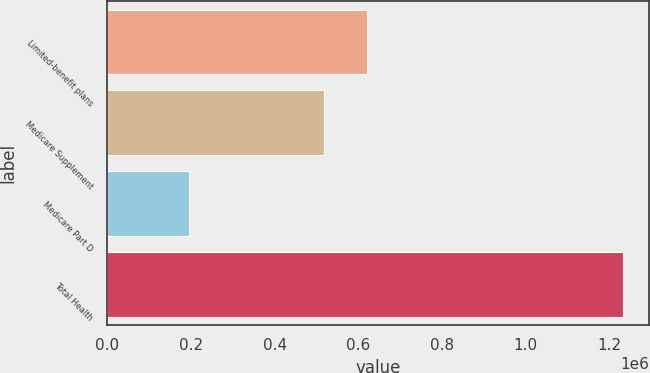Convert chart. <chart><loc_0><loc_0><loc_500><loc_500><bar_chart><fcel>Limited-benefit plans<fcel>Medicare Supplement<fcel>Medicare Part D<fcel>Total Health<nl><fcel>622025<fcel>518205<fcel>195685<fcel>1.23388e+06<nl></chart> 